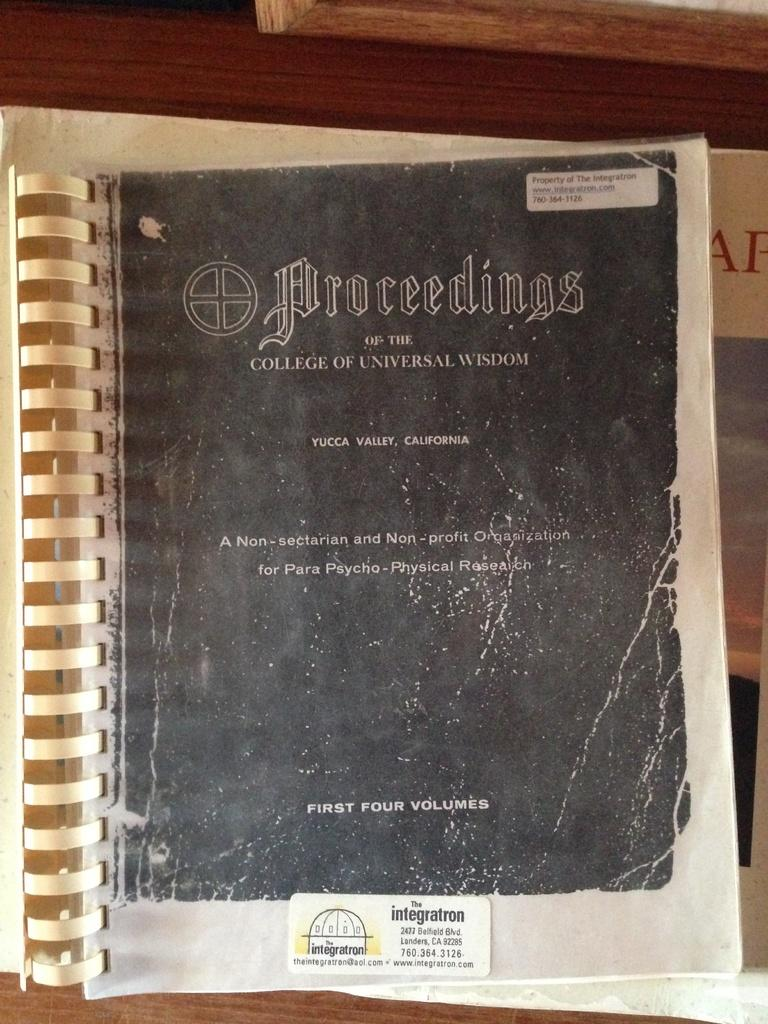<image>
Relay a brief, clear account of the picture shown. A book is entitled "Proceedings of the College of Universal Wisdom." 